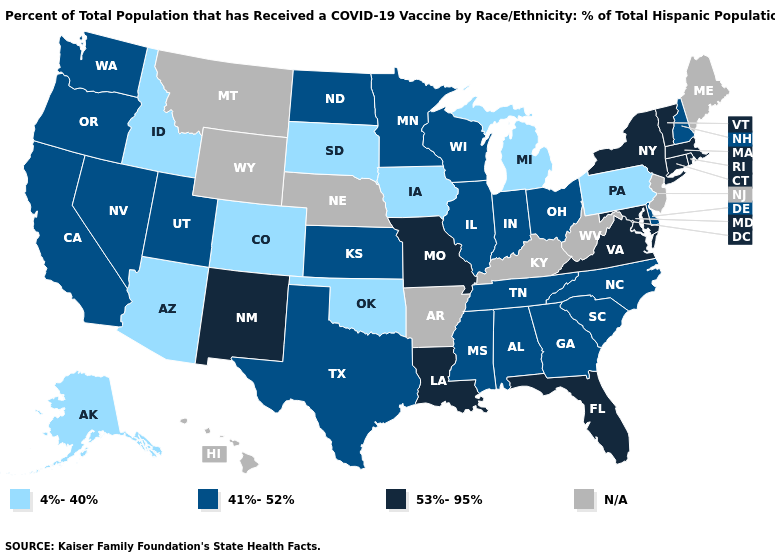Does New York have the highest value in the Northeast?
Be succinct. Yes. Does Washington have the lowest value in the West?
Be succinct. No. Which states have the lowest value in the MidWest?
Write a very short answer. Iowa, Michigan, South Dakota. What is the value of Illinois?
Give a very brief answer. 41%-52%. Name the states that have a value in the range 4%-40%?
Be succinct. Alaska, Arizona, Colorado, Idaho, Iowa, Michigan, Oklahoma, Pennsylvania, South Dakota. Which states have the highest value in the USA?
Answer briefly. Connecticut, Florida, Louisiana, Maryland, Massachusetts, Missouri, New Mexico, New York, Rhode Island, Vermont, Virginia. What is the value of New York?
Give a very brief answer. 53%-95%. What is the value of Arkansas?
Give a very brief answer. N/A. What is the value of Ohio?
Quick response, please. 41%-52%. What is the lowest value in the West?
Quick response, please. 4%-40%. Name the states that have a value in the range 53%-95%?
Quick response, please. Connecticut, Florida, Louisiana, Maryland, Massachusetts, Missouri, New Mexico, New York, Rhode Island, Vermont, Virginia. Is the legend a continuous bar?
Give a very brief answer. No. Name the states that have a value in the range 53%-95%?
Give a very brief answer. Connecticut, Florida, Louisiana, Maryland, Massachusetts, Missouri, New Mexico, New York, Rhode Island, Vermont, Virginia. What is the value of Nebraska?
Quick response, please. N/A. Name the states that have a value in the range N/A?
Concise answer only. Arkansas, Hawaii, Kentucky, Maine, Montana, Nebraska, New Jersey, West Virginia, Wyoming. 